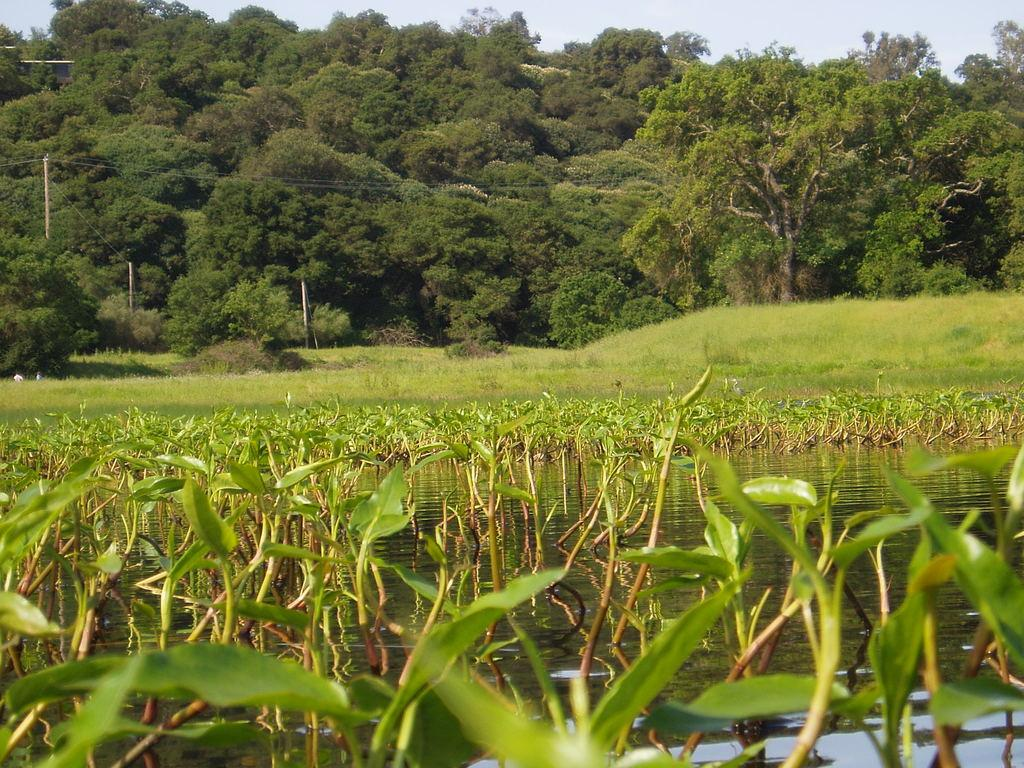What type of vegetation can be seen in the image? There are plants, grass, and trees visible in the image. What is the primary element present in the image? Water is visible in the image. What structures can be seen in the image? There are poles and wires in the image. What is visible in the background of the image? The sky is visible in the background of the image. How much money is being exchanged between the plants in the image? There is no money present in the image, as it features plants, water, grass, poles, wires, trees, and the sky. What type of office can be seen in the background of the image? There is no office present in the image; it primarily consists of natural elements such as plants, water, grass, poles, wires, trees, and the sky. 